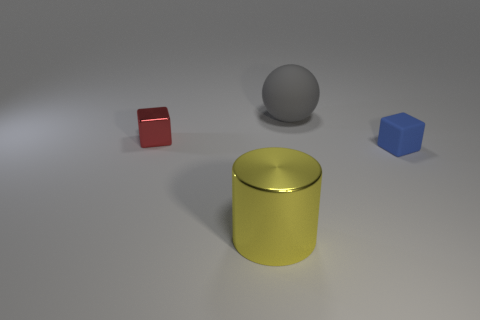What number of other things are the same size as the cylinder?
Offer a very short reply. 1. There is a cube on the right side of the gray matte thing; is it the same size as the tiny red block?
Your answer should be compact. Yes. There is a cube that is the same size as the blue matte object; what is its color?
Your answer should be compact. Red. Are there any big yellow metallic cylinders to the right of the big yellow thing in front of the large object behind the cylinder?
Ensure brevity in your answer.  No. There is a block that is right of the large metallic cylinder; what is it made of?
Your answer should be very brief. Rubber. There is a big yellow metal thing; is it the same shape as the tiny object that is left of the tiny rubber object?
Provide a succinct answer. No. Are there the same number of tiny rubber blocks that are in front of the blue rubber block and red shiny objects that are to the left of the big yellow thing?
Your answer should be compact. No. What number of other things are the same material as the small blue thing?
Ensure brevity in your answer.  1. What number of rubber things are either large yellow cylinders or red cylinders?
Provide a succinct answer. 0. Does the small thing that is left of the blue thing have the same shape as the large rubber object?
Your answer should be very brief. No. 